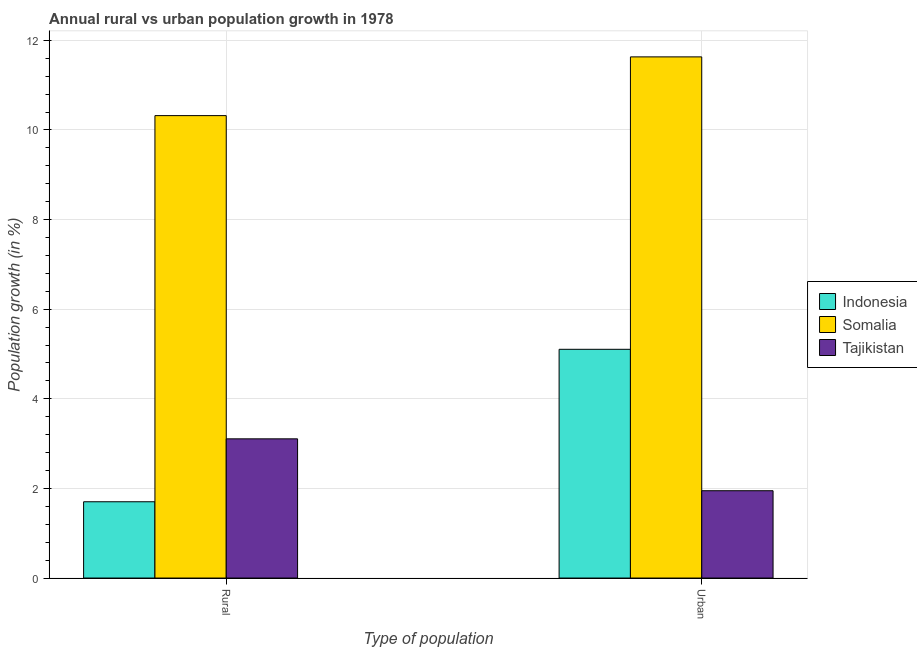How many different coloured bars are there?
Provide a succinct answer. 3. Are the number of bars per tick equal to the number of legend labels?
Provide a short and direct response. Yes. Are the number of bars on each tick of the X-axis equal?
Offer a terse response. Yes. What is the label of the 2nd group of bars from the left?
Offer a terse response. Urban . What is the rural population growth in Somalia?
Your answer should be very brief. 10.32. Across all countries, what is the maximum rural population growth?
Your answer should be compact. 10.32. Across all countries, what is the minimum rural population growth?
Provide a succinct answer. 1.7. In which country was the rural population growth maximum?
Provide a succinct answer. Somalia. In which country was the urban population growth minimum?
Your response must be concise. Tajikistan. What is the total rural population growth in the graph?
Offer a very short reply. 15.13. What is the difference between the rural population growth in Indonesia and that in Somalia?
Ensure brevity in your answer.  -8.62. What is the difference between the rural population growth in Somalia and the urban population growth in Indonesia?
Ensure brevity in your answer.  5.21. What is the average urban population growth per country?
Your answer should be compact. 6.23. What is the difference between the urban population growth and rural population growth in Somalia?
Your answer should be very brief. 1.31. In how many countries, is the urban population growth greater than 11.6 %?
Your answer should be very brief. 1. What is the ratio of the urban population growth in Indonesia to that in Somalia?
Ensure brevity in your answer.  0.44. Is the rural population growth in Somalia less than that in Tajikistan?
Provide a short and direct response. No. What does the 2nd bar from the right in Rural represents?
Keep it short and to the point. Somalia. How many bars are there?
Make the answer very short. 6. How many countries are there in the graph?
Provide a short and direct response. 3. What is the difference between two consecutive major ticks on the Y-axis?
Provide a short and direct response. 2. Are the values on the major ticks of Y-axis written in scientific E-notation?
Offer a very short reply. No. Does the graph contain grids?
Keep it short and to the point. Yes. How are the legend labels stacked?
Provide a succinct answer. Vertical. What is the title of the graph?
Offer a terse response. Annual rural vs urban population growth in 1978. Does "Grenada" appear as one of the legend labels in the graph?
Your answer should be very brief. No. What is the label or title of the X-axis?
Offer a very short reply. Type of population. What is the label or title of the Y-axis?
Ensure brevity in your answer.  Population growth (in %). What is the Population growth (in %) of Indonesia in Rural?
Your answer should be very brief. 1.7. What is the Population growth (in %) in Somalia in Rural?
Offer a terse response. 10.32. What is the Population growth (in %) of Tajikistan in Rural?
Offer a terse response. 3.11. What is the Population growth (in %) in Indonesia in Urban ?
Your answer should be very brief. 5.1. What is the Population growth (in %) in Somalia in Urban ?
Your response must be concise. 11.63. What is the Population growth (in %) of Tajikistan in Urban ?
Provide a short and direct response. 1.95. Across all Type of population, what is the maximum Population growth (in %) in Indonesia?
Offer a terse response. 5.1. Across all Type of population, what is the maximum Population growth (in %) in Somalia?
Your answer should be compact. 11.63. Across all Type of population, what is the maximum Population growth (in %) of Tajikistan?
Provide a succinct answer. 3.11. Across all Type of population, what is the minimum Population growth (in %) of Indonesia?
Your response must be concise. 1.7. Across all Type of population, what is the minimum Population growth (in %) of Somalia?
Your response must be concise. 10.32. Across all Type of population, what is the minimum Population growth (in %) of Tajikistan?
Offer a very short reply. 1.95. What is the total Population growth (in %) of Indonesia in the graph?
Provide a succinct answer. 6.81. What is the total Population growth (in %) of Somalia in the graph?
Offer a terse response. 21.95. What is the total Population growth (in %) of Tajikistan in the graph?
Your answer should be very brief. 5.06. What is the difference between the Population growth (in %) in Indonesia in Rural and that in Urban ?
Make the answer very short. -3.4. What is the difference between the Population growth (in %) of Somalia in Rural and that in Urban ?
Your response must be concise. -1.31. What is the difference between the Population growth (in %) of Tajikistan in Rural and that in Urban ?
Your answer should be compact. 1.16. What is the difference between the Population growth (in %) in Indonesia in Rural and the Population growth (in %) in Somalia in Urban?
Your answer should be compact. -9.93. What is the difference between the Population growth (in %) of Indonesia in Rural and the Population growth (in %) of Tajikistan in Urban?
Your answer should be compact. -0.25. What is the difference between the Population growth (in %) in Somalia in Rural and the Population growth (in %) in Tajikistan in Urban?
Ensure brevity in your answer.  8.37. What is the average Population growth (in %) in Indonesia per Type of population?
Ensure brevity in your answer.  3.4. What is the average Population growth (in %) of Somalia per Type of population?
Provide a succinct answer. 10.97. What is the average Population growth (in %) of Tajikistan per Type of population?
Provide a short and direct response. 2.53. What is the difference between the Population growth (in %) of Indonesia and Population growth (in %) of Somalia in Rural?
Make the answer very short. -8.62. What is the difference between the Population growth (in %) of Indonesia and Population growth (in %) of Tajikistan in Rural?
Provide a succinct answer. -1.4. What is the difference between the Population growth (in %) in Somalia and Population growth (in %) in Tajikistan in Rural?
Your answer should be compact. 7.21. What is the difference between the Population growth (in %) in Indonesia and Population growth (in %) in Somalia in Urban ?
Your answer should be compact. -6.53. What is the difference between the Population growth (in %) in Indonesia and Population growth (in %) in Tajikistan in Urban ?
Provide a succinct answer. 3.16. What is the difference between the Population growth (in %) in Somalia and Population growth (in %) in Tajikistan in Urban ?
Your answer should be compact. 9.68. What is the ratio of the Population growth (in %) of Indonesia in Rural to that in Urban ?
Provide a short and direct response. 0.33. What is the ratio of the Population growth (in %) of Somalia in Rural to that in Urban ?
Offer a very short reply. 0.89. What is the ratio of the Population growth (in %) of Tajikistan in Rural to that in Urban ?
Offer a very short reply. 1.59. What is the difference between the highest and the second highest Population growth (in %) in Indonesia?
Provide a short and direct response. 3.4. What is the difference between the highest and the second highest Population growth (in %) in Somalia?
Your answer should be compact. 1.31. What is the difference between the highest and the second highest Population growth (in %) in Tajikistan?
Your response must be concise. 1.16. What is the difference between the highest and the lowest Population growth (in %) in Indonesia?
Keep it short and to the point. 3.4. What is the difference between the highest and the lowest Population growth (in %) of Somalia?
Offer a very short reply. 1.31. What is the difference between the highest and the lowest Population growth (in %) of Tajikistan?
Make the answer very short. 1.16. 